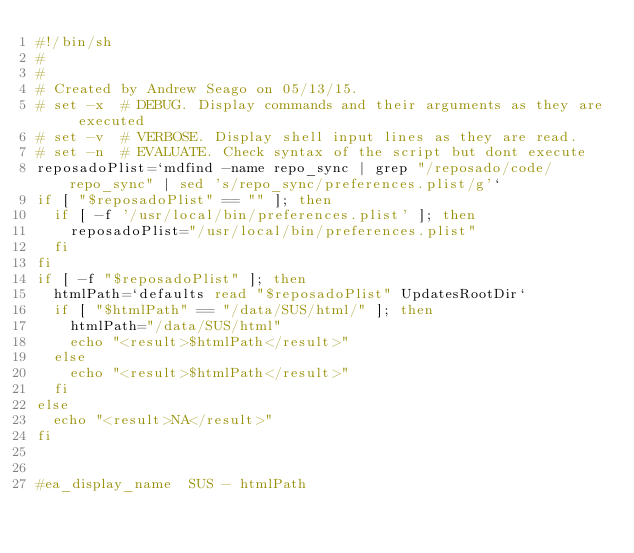Convert code to text. <code><loc_0><loc_0><loc_500><loc_500><_Bash_>#!/bin/sh
#
#
# Created by Andrew Seago on 05/13/15.
# set -x	# DEBUG. Display commands and their arguments as they are executed
# set -v	# VERBOSE. Display shell input lines as they are read.
# set -n	# EVALUATE. Check syntax of the script but dont execute
reposadoPlist=`mdfind -name repo_sync | grep "/reposado/code/repo_sync" | sed 's/repo_sync/preferences.plist/g'`
if [ "$reposadoPlist" == "" ]; then
	if [ -f '/usr/local/bin/preferences.plist' ]; then
		reposadoPlist="/usr/local/bin/preferences.plist"
	fi
fi
if [ -f "$reposadoPlist" ]; then
	htmlPath=`defaults read "$reposadoPlist" UpdatesRootDir`
	if [ "$htmlPath" == "/data/SUS/html/" ]; then
		htmlPath="/data/SUS/html"
		echo "<result>$htmlPath</result>"
	else
		echo "<result>$htmlPath</result>"
	fi
else
	echo "<result>NA</result>"
fi


#ea_display_name	SUS - htmlPath
</code> 